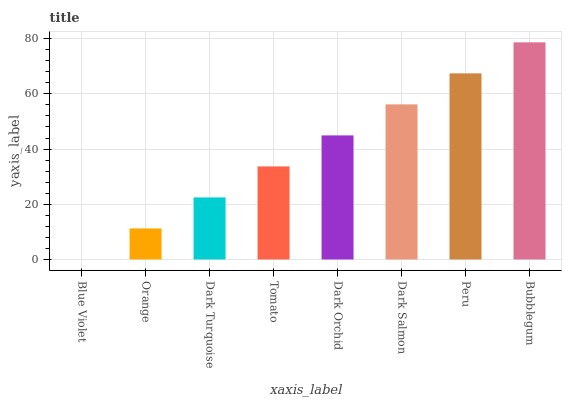Is Blue Violet the minimum?
Answer yes or no. Yes. Is Bubblegum the maximum?
Answer yes or no. Yes. Is Orange the minimum?
Answer yes or no. No. Is Orange the maximum?
Answer yes or no. No. Is Orange greater than Blue Violet?
Answer yes or no. Yes. Is Blue Violet less than Orange?
Answer yes or no. Yes. Is Blue Violet greater than Orange?
Answer yes or no. No. Is Orange less than Blue Violet?
Answer yes or no. No. Is Dark Orchid the high median?
Answer yes or no. Yes. Is Tomato the low median?
Answer yes or no. Yes. Is Peru the high median?
Answer yes or no. No. Is Dark Turquoise the low median?
Answer yes or no. No. 